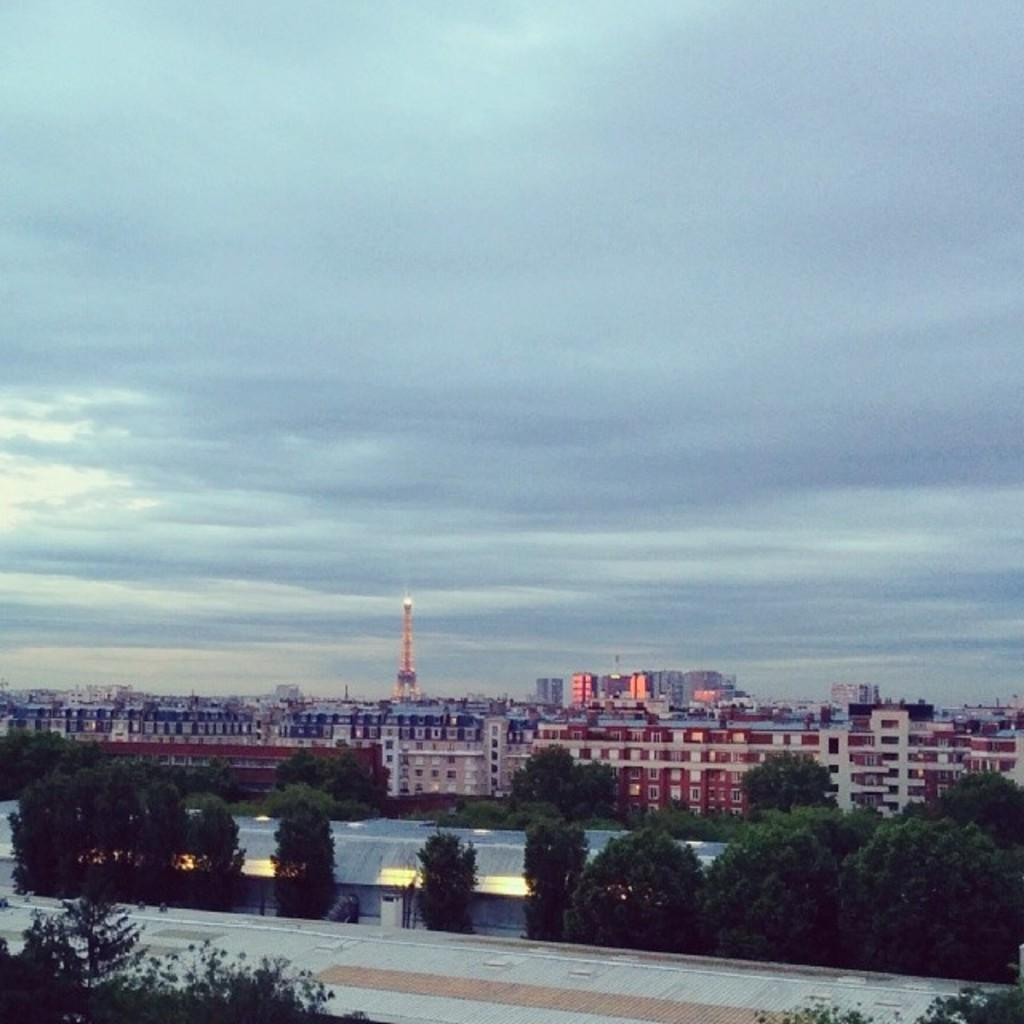What type of natural elements can be seen in the image? There are trees in the image. What type of man-made structures are present in the image? There are buildings in the image. Where are the buildings located in relation to the image? The buildings are located on the bottom side of the image. What can be seen in the background of the image? There are clouds and the sky visible in the background of the image. What type of wine is being served at the picnic in the image? There is no picnic or wine present in the image; it features trees, buildings, clouds, and the sky. How many gloves can be seen on the trees in the image? There are no gloves present on the trees in the image; it only features trees and buildings. 